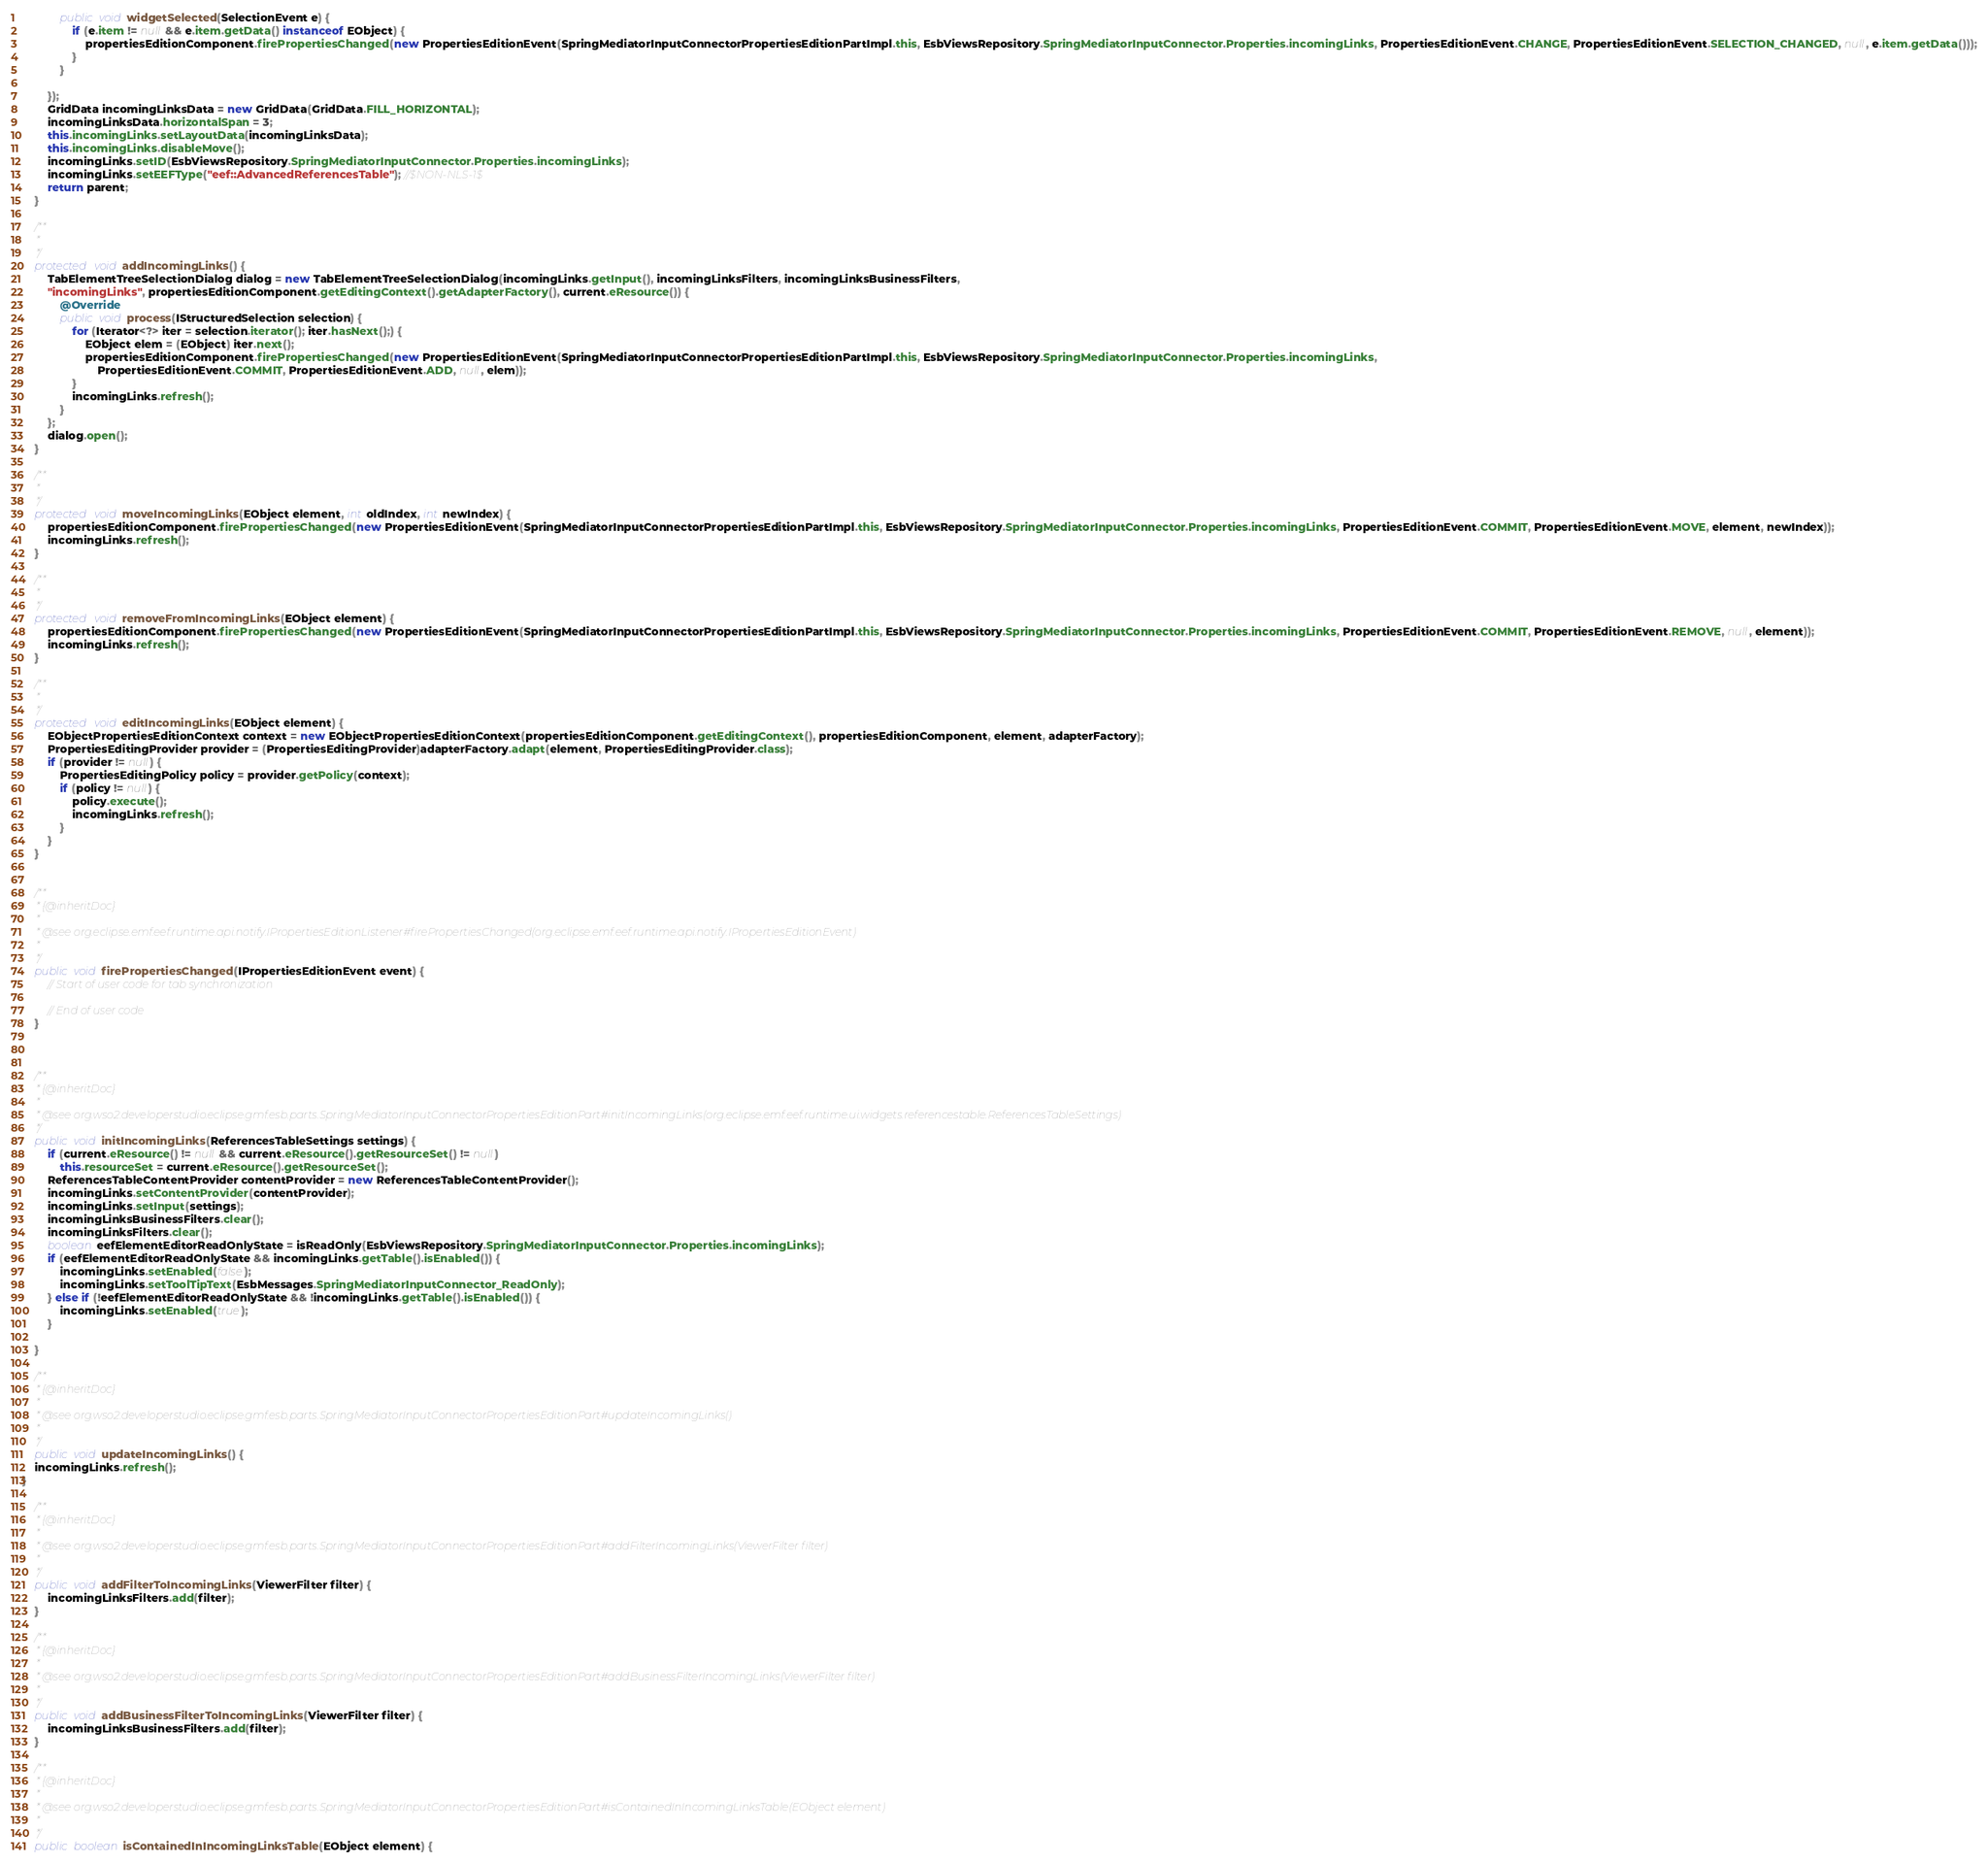<code> <loc_0><loc_0><loc_500><loc_500><_Java_>			public void widgetSelected(SelectionEvent e) {
				if (e.item != null && e.item.getData() instanceof EObject) {
					propertiesEditionComponent.firePropertiesChanged(new PropertiesEditionEvent(SpringMediatorInputConnectorPropertiesEditionPartImpl.this, EsbViewsRepository.SpringMediatorInputConnector.Properties.incomingLinks, PropertiesEditionEvent.CHANGE, PropertiesEditionEvent.SELECTION_CHANGED, null, e.item.getData()));
				}
			}
			
		});
		GridData incomingLinksData = new GridData(GridData.FILL_HORIZONTAL);
		incomingLinksData.horizontalSpan = 3;
		this.incomingLinks.setLayoutData(incomingLinksData);
		this.incomingLinks.disableMove();
		incomingLinks.setID(EsbViewsRepository.SpringMediatorInputConnector.Properties.incomingLinks);
		incomingLinks.setEEFType("eef::AdvancedReferencesTable"); //$NON-NLS-1$
		return parent;
	}

	/**
	 * 
	 */
	protected void addIncomingLinks() {
		TabElementTreeSelectionDialog dialog = new TabElementTreeSelectionDialog(incomingLinks.getInput(), incomingLinksFilters, incomingLinksBusinessFilters,
		"incomingLinks", propertiesEditionComponent.getEditingContext().getAdapterFactory(), current.eResource()) {
			@Override
			public void process(IStructuredSelection selection) {
				for (Iterator<?> iter = selection.iterator(); iter.hasNext();) {
					EObject elem = (EObject) iter.next();
					propertiesEditionComponent.firePropertiesChanged(new PropertiesEditionEvent(SpringMediatorInputConnectorPropertiesEditionPartImpl.this, EsbViewsRepository.SpringMediatorInputConnector.Properties.incomingLinks,
						PropertiesEditionEvent.COMMIT, PropertiesEditionEvent.ADD, null, elem));
				}
				incomingLinks.refresh();
			}
		};
		dialog.open();
	}

	/**
	 * 
	 */
	protected void moveIncomingLinks(EObject element, int oldIndex, int newIndex) {
		propertiesEditionComponent.firePropertiesChanged(new PropertiesEditionEvent(SpringMediatorInputConnectorPropertiesEditionPartImpl.this, EsbViewsRepository.SpringMediatorInputConnector.Properties.incomingLinks, PropertiesEditionEvent.COMMIT, PropertiesEditionEvent.MOVE, element, newIndex));
		incomingLinks.refresh();
	}

	/**
	 * 
	 */
	protected void removeFromIncomingLinks(EObject element) {
		propertiesEditionComponent.firePropertiesChanged(new PropertiesEditionEvent(SpringMediatorInputConnectorPropertiesEditionPartImpl.this, EsbViewsRepository.SpringMediatorInputConnector.Properties.incomingLinks, PropertiesEditionEvent.COMMIT, PropertiesEditionEvent.REMOVE, null, element));
		incomingLinks.refresh();
	}

	/**
	 * 
	 */
	protected void editIncomingLinks(EObject element) {
		EObjectPropertiesEditionContext context = new EObjectPropertiesEditionContext(propertiesEditionComponent.getEditingContext(), propertiesEditionComponent, element, adapterFactory);
		PropertiesEditingProvider provider = (PropertiesEditingProvider)adapterFactory.adapt(element, PropertiesEditingProvider.class);
		if (provider != null) {
			PropertiesEditingPolicy policy = provider.getPolicy(context);
			if (policy != null) {
				policy.execute();
				incomingLinks.refresh();
			}
		}
	}


	/**
	 * {@inheritDoc}
	 * 
	 * @see org.eclipse.emf.eef.runtime.api.notify.IPropertiesEditionListener#firePropertiesChanged(org.eclipse.emf.eef.runtime.api.notify.IPropertiesEditionEvent)
	 * 
	 */
	public void firePropertiesChanged(IPropertiesEditionEvent event) {
		// Start of user code for tab synchronization
		
		// End of user code
	}



	/**
	 * {@inheritDoc}
	 * 
	 * @see org.wso2.developerstudio.eclipse.gmf.esb.parts.SpringMediatorInputConnectorPropertiesEditionPart#initIncomingLinks(org.eclipse.emf.eef.runtime.ui.widgets.referencestable.ReferencesTableSettings)
	 */
	public void initIncomingLinks(ReferencesTableSettings settings) {
		if (current.eResource() != null && current.eResource().getResourceSet() != null)
			this.resourceSet = current.eResource().getResourceSet();
		ReferencesTableContentProvider contentProvider = new ReferencesTableContentProvider();
		incomingLinks.setContentProvider(contentProvider);
		incomingLinks.setInput(settings);
		incomingLinksBusinessFilters.clear();
		incomingLinksFilters.clear();
		boolean eefElementEditorReadOnlyState = isReadOnly(EsbViewsRepository.SpringMediatorInputConnector.Properties.incomingLinks);
		if (eefElementEditorReadOnlyState && incomingLinks.getTable().isEnabled()) {
			incomingLinks.setEnabled(false);
			incomingLinks.setToolTipText(EsbMessages.SpringMediatorInputConnector_ReadOnly);
		} else if (!eefElementEditorReadOnlyState && !incomingLinks.getTable().isEnabled()) {
			incomingLinks.setEnabled(true);
		}
		
	}

	/**
	 * {@inheritDoc}
	 * 
	 * @see org.wso2.developerstudio.eclipse.gmf.esb.parts.SpringMediatorInputConnectorPropertiesEditionPart#updateIncomingLinks()
	 * 
	 */
	public void updateIncomingLinks() {
	incomingLinks.refresh();
}

	/**
	 * {@inheritDoc}
	 * 
	 * @see org.wso2.developerstudio.eclipse.gmf.esb.parts.SpringMediatorInputConnectorPropertiesEditionPart#addFilterIncomingLinks(ViewerFilter filter)
	 * 
	 */
	public void addFilterToIncomingLinks(ViewerFilter filter) {
		incomingLinksFilters.add(filter);
	}

	/**
	 * {@inheritDoc}
	 * 
	 * @see org.wso2.developerstudio.eclipse.gmf.esb.parts.SpringMediatorInputConnectorPropertiesEditionPart#addBusinessFilterIncomingLinks(ViewerFilter filter)
	 * 
	 */
	public void addBusinessFilterToIncomingLinks(ViewerFilter filter) {
		incomingLinksBusinessFilters.add(filter);
	}

	/**
	 * {@inheritDoc}
	 * 
	 * @see org.wso2.developerstudio.eclipse.gmf.esb.parts.SpringMediatorInputConnectorPropertiesEditionPart#isContainedInIncomingLinksTable(EObject element)
	 * 
	 */
	public boolean isContainedInIncomingLinksTable(EObject element) {</code> 